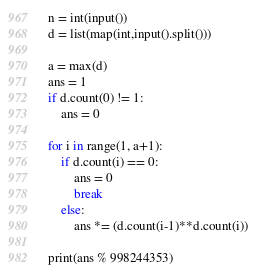<code> <loc_0><loc_0><loc_500><loc_500><_Python_>n = int(input())
d = list(map(int,input().split()))

a = max(d)
ans = 1
if d.count(0) != 1:
    ans = 0

for i in range(1, a+1):
    if d.count(i) == 0:
        ans = 0
        break
    else:
        ans *= (d.count(i-1)**d.count(i))
        
print(ans % 998244353)</code> 